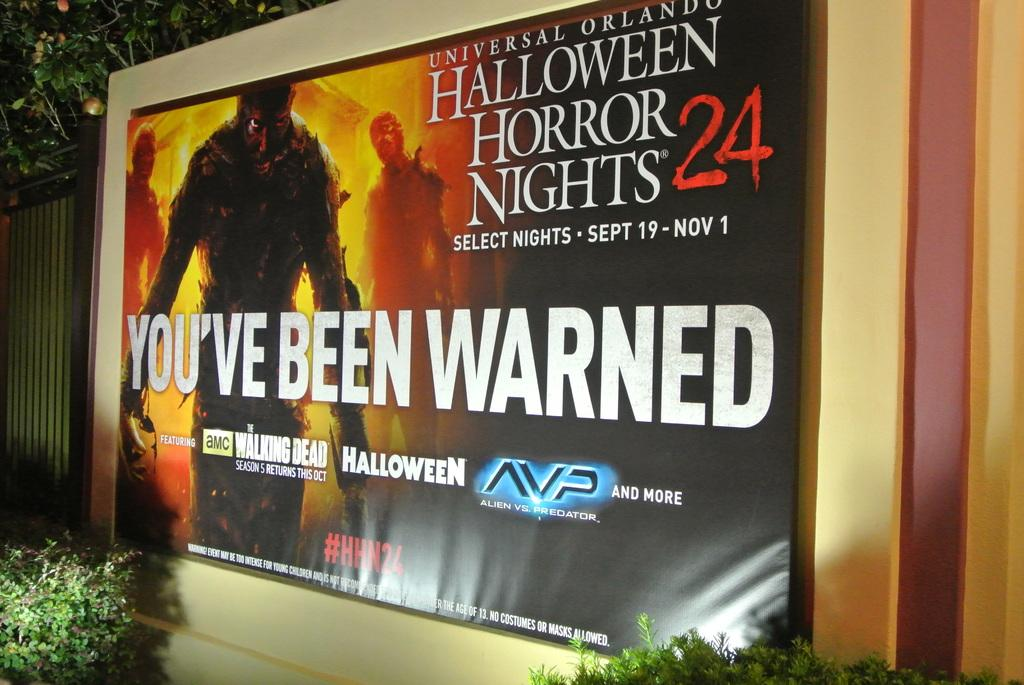<image>
Write a terse but informative summary of the picture. A large poster that displays a sign that says You've been Warned and a scary character beside 